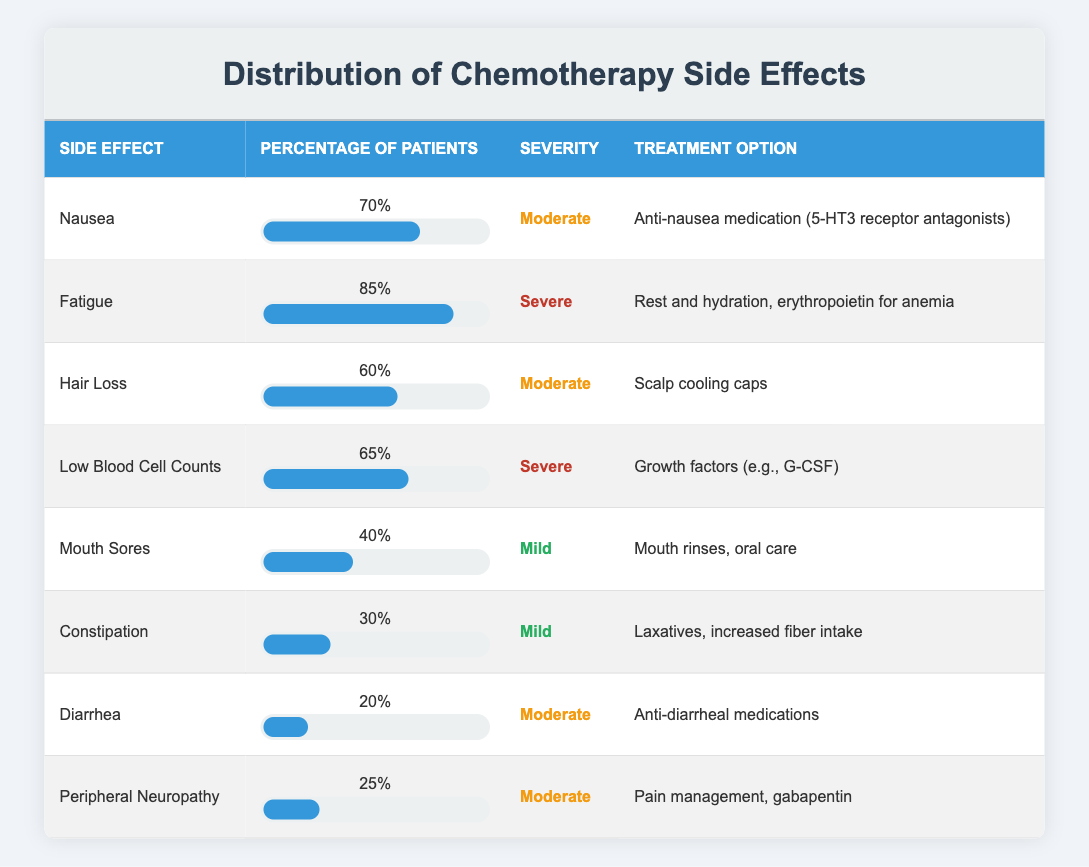What percentage of patients experience fatigue? The table shows that fatigue affects 85% of patients. This is directly retrieved from the "Percentage of Patients" column corresponding to the "Fatigue" row.
Answer: 85% Which side effect has the lowest percentage of patients affected? Looking at the table, constipation is noted to affect 30% of patients, which is the lowest percentage among all the listed side effects.
Answer: Constipation Is the treatment option for low blood cell counts an anti-nausea medication? The treatment option for low blood cell counts is growth factors (e.g., G-CSF), not an anti-nausea medication, which is specifically listed for nausea.
Answer: No What is the average percentage of patients experiencing mild side effects? The mild side effects listed are mouth sores (40%) and constipation (30%). To find the average, add these percentages (40 + 30 = 70) and divide by the number of mild side effects (2). So, the average is 70 / 2 = 35%.
Answer: 35% What is the most severe side effect experienced by patients undergoing chemotherapy? Referring to the "Severity" column, fatigue and low blood cell counts are both classified as severe. Therefore, both are considered the most severe side effects. This is derived by comparing the severity levels across all entries.
Answer: Fatigue and Low Blood Cell Counts How many side effects have a moderate severity rating? The table shows that nausea, hair loss, diarrhea, and peripheral neuropathy are categorized as moderate severity. Adding them gives a total of 4 side effects with this rating.
Answer: 4 Which treatment option is used for diarrhea? According to the table, anti-diarrheal medications are the specified treatment option for diarrhea. This information is located in the "Treatment Option" column corresponding to the "Diarrhea" row.
Answer: Anti-diarrheal medications Is the percentage of patients with hair loss greater than those with mouth sores? The percentage for hair loss is 60%, while for mouth sores it is 40%. Since 60% is greater than 40%, the statement is true.
Answer: Yes 